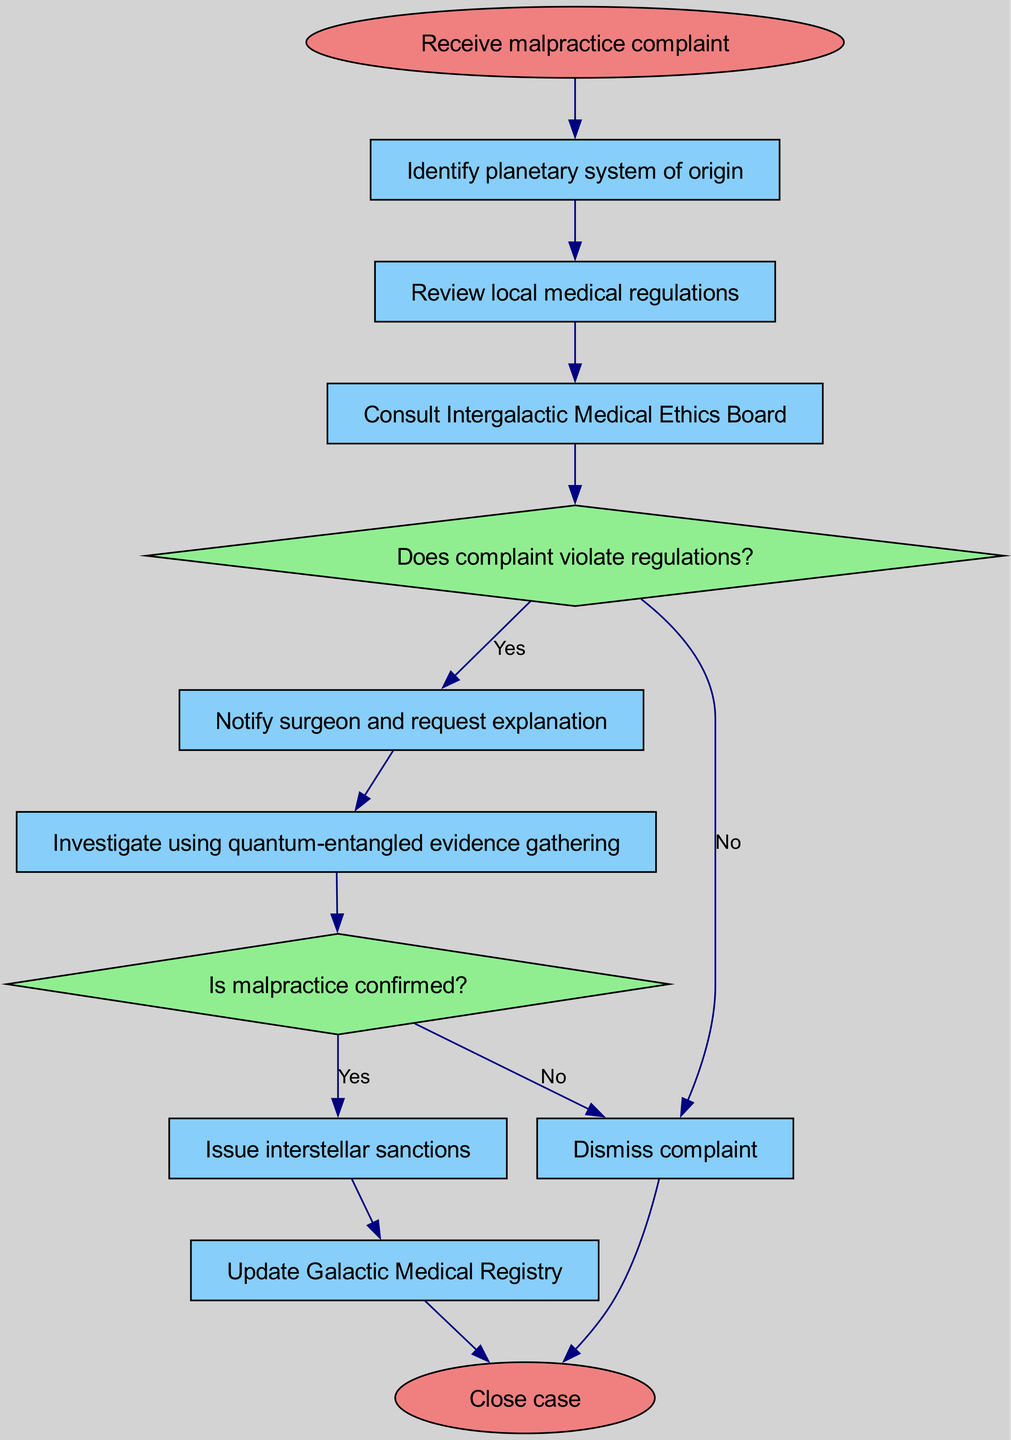What is the first step in the procedure? The first step in the procedure is indicated by the node following "Receive malpractice complaint," which is "Identify planetary system of origin."
Answer: Identify planetary system of origin How many steps are there after the initial complaint is received? After the initial complaint, the diagram includes six steps before arriving at the end, specifically steps labeled "step1" through "step8," excluding the start and end nodes.
Answer: Six steps What action is taken if the complaint does not violate regulations? If the complaint does not violate regulations, indicated by the decision node's "No" path, the action taken is to "Dismiss complaint."
Answer: Dismiss complaint What happens immediately after notifying the surgeon? After notifying the surgeon and requesting an explanation, the next step is to "Investigate using quantum-entangled evidence gathering."
Answer: Investigate using quantum-entangled evidence gathering What is the final action in the process after updating the Galactic Medical Registry? The final action in the process, indicated by the end node, is "Close case," which is reached after updating the Galactic Medical Registry.
Answer: Close case What decision occurs before issuing interstellar sanctions? Before issuing interstellar sanctions, a decision must be made about whether malpractice is confirmed, which is indicated by the decision node's pathway.
Answer: Is malpractice confirmed? How does the flow proceed if malpractice is confirmed? If malpractice is confirmed (Yes), the flow proceeds to "Issue interstellar sanctions," which is the next action taken in that pathway.
Answer: Issue interstellar sanctions What shape is used to represent decision points in the diagram? Decision points in the diagram are represented using a diamond shape, distinguishing them from other nodes.
Answer: Diamond shape What does the flowchart indicate to do after completing the investigation? After completing the investigation, the flowchart indicates to make a decision, specifically "Is malpractice confirmed?" leading to determining the following actions.
Answer: Is malpractice confirmed? 